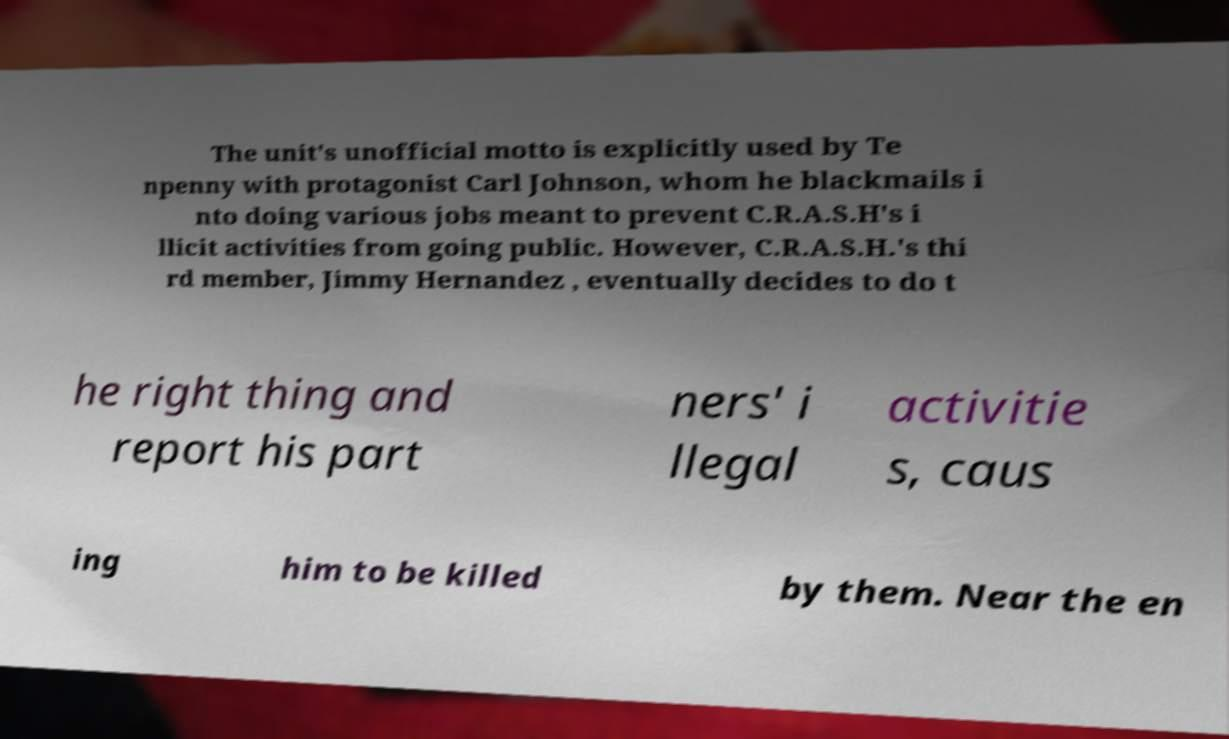I need the written content from this picture converted into text. Can you do that? The unit's unofficial motto is explicitly used by Te npenny with protagonist Carl Johnson, whom he blackmails i nto doing various jobs meant to prevent C.R.A.S.H's i llicit activities from going public. However, C.R.A.S.H.'s thi rd member, Jimmy Hernandez , eventually decides to do t he right thing and report his part ners' i llegal activitie s, caus ing him to be killed by them. Near the en 